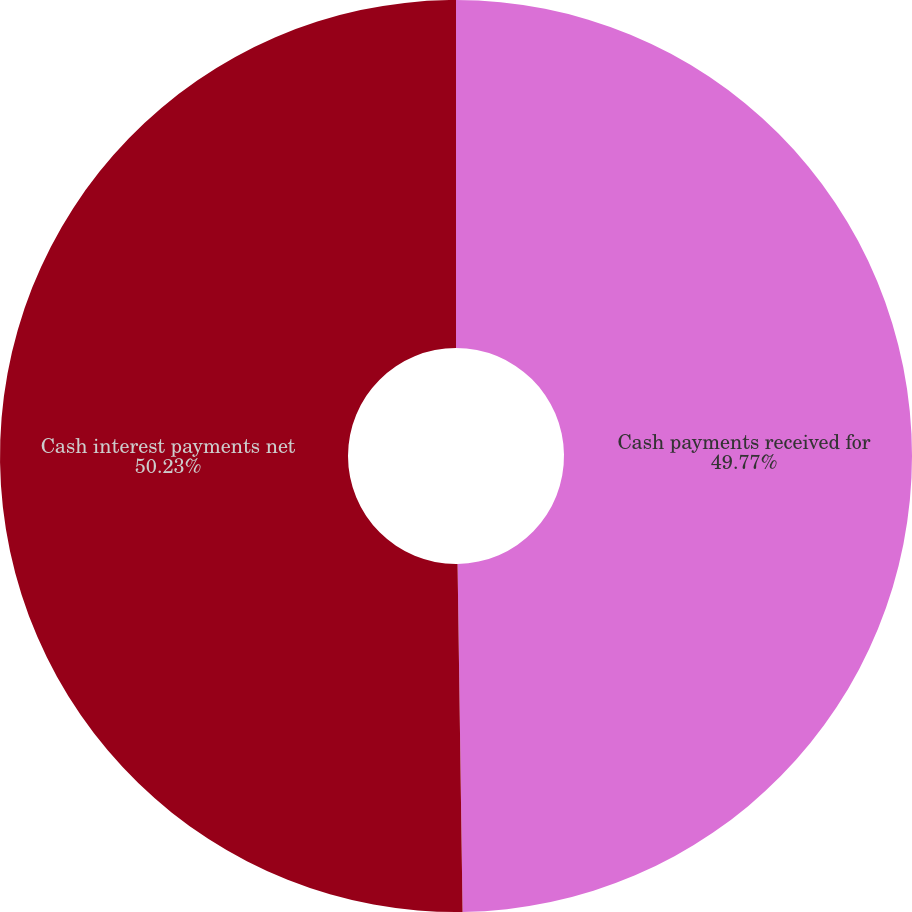Convert chart. <chart><loc_0><loc_0><loc_500><loc_500><pie_chart><fcel>Cash payments received for<fcel>Cash interest payments net<nl><fcel>49.77%<fcel>50.23%<nl></chart> 